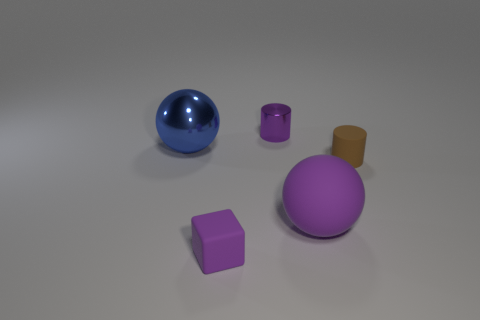Subtract all purple cylinders. How many cylinders are left? 1 Subtract all cylinders. How many objects are left? 3 Subtract 1 spheres. How many spheres are left? 1 Add 1 purple rubber things. How many objects exist? 6 Add 4 rubber cubes. How many rubber cubes are left? 5 Add 4 balls. How many balls exist? 6 Subtract 0 cyan balls. How many objects are left? 5 Subtract all purple cylinders. Subtract all purple cubes. How many cylinders are left? 1 Subtract all yellow spheres. How many brown cylinders are left? 1 Subtract all small green metal things. Subtract all spheres. How many objects are left? 3 